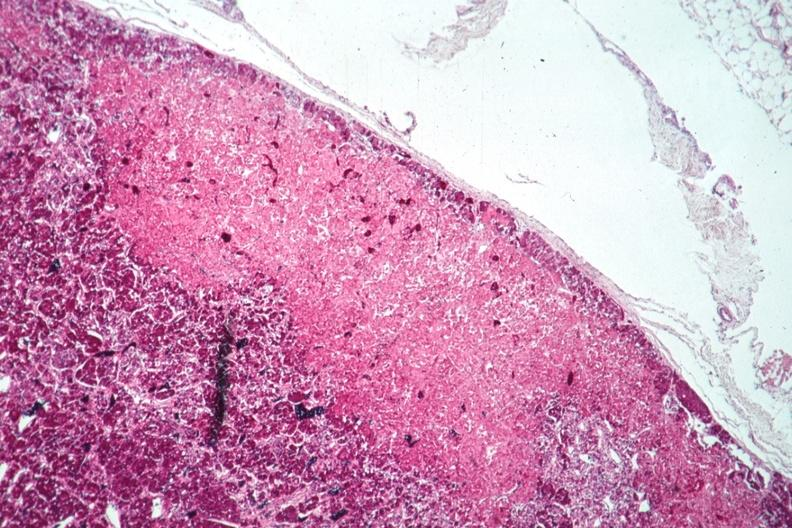where is this part in the figure?
Answer the question using a single word or phrase. Endocrine system 